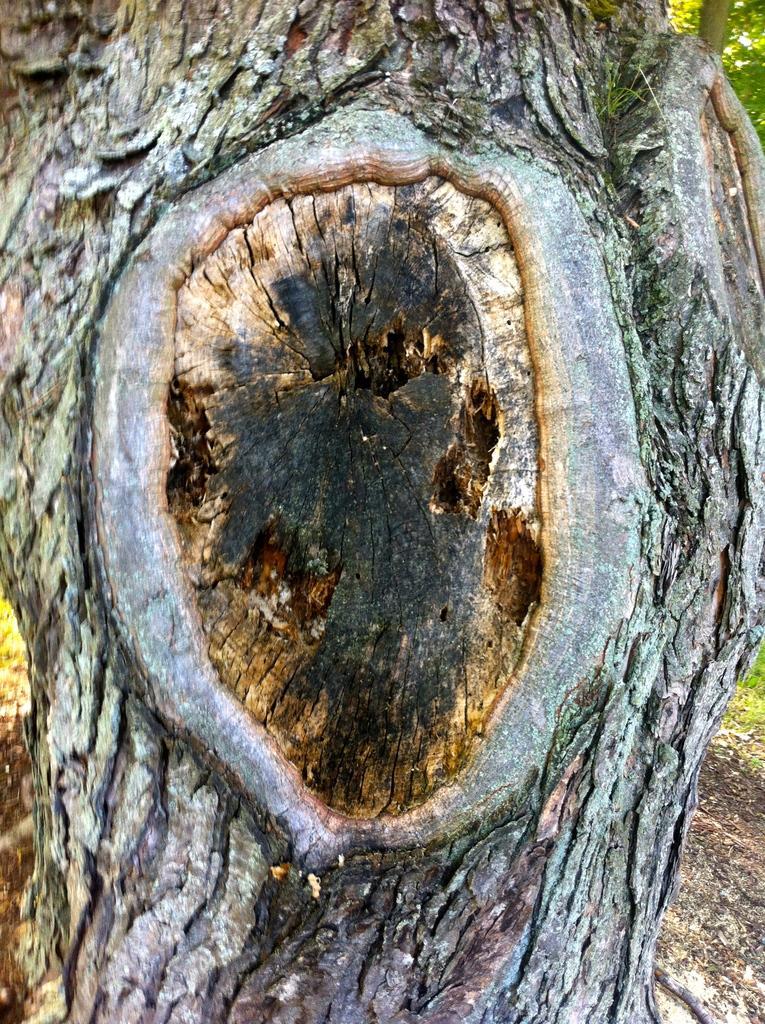How would you summarize this image in a sentence or two? In this image we can see the trunk of a tree, leaves and ground. 